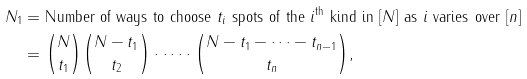Convert formula to latex. <formula><loc_0><loc_0><loc_500><loc_500>N _ { 1 } & = \text {Number of ways to choose } t _ { i } \text { spots of the } i ^ { \text {th} } \text { kind in } [ N ] \text { as } i \text { varies over } [ n ] \\ & = \binom { N } { t _ { 1 } } \binom { N - t _ { 1 } } { t _ { 2 } } \cdot \dots \cdot \binom { N - t _ { 1 } - \dots - t _ { n - 1 } } { t _ { n } } ,</formula> 